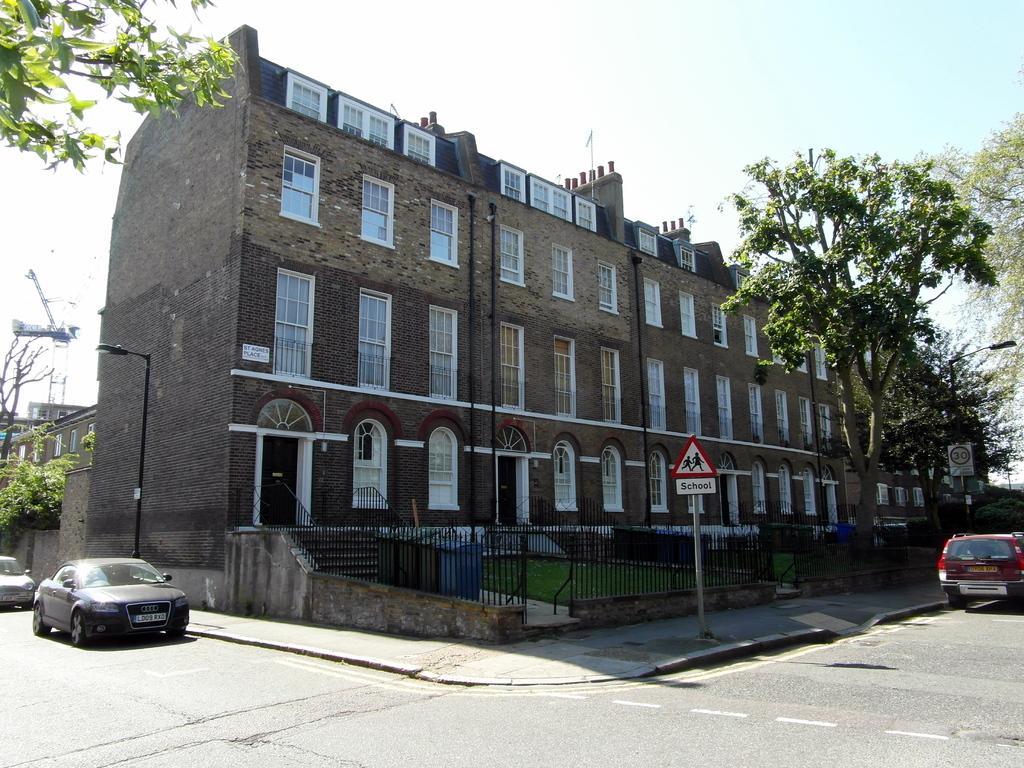In one or two sentences, can you explain what this image depicts? In this image, I can see a building with windows and doors. In front of a building, there are dustbins, iron grilles and a signboard to a pole. There are cars on the road. On the left side of the image, I can see a crane and a street light. On the right and left side of the image, there are trees. In the background, there is the sky. 